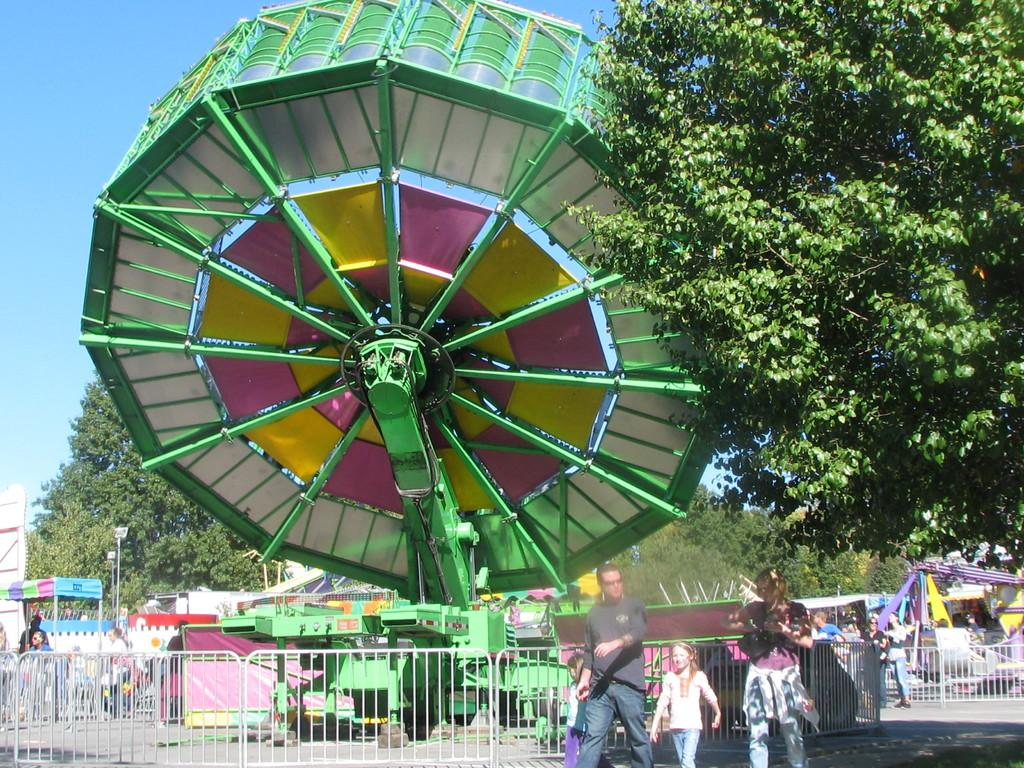What is happening in the image? There is an exhibition in the image. What can be seen surrounding the exhibition area? There is a fence and trees in the image. Are there any people present in the image? Yes, there are people in the image. What is on the ground in the image? There are objects on the ground in the image. What is visible in the background of the image? The sky is visible in the background of the image. What type of bead is being used to decorate the birthday cake in the image? There is no birthday cake or beads present in the image; it features an exhibition with a fence, trees, people, objects on the ground, and a visible sky. --- Facts: 1. There is a car in the image. 2. The car is red. 3. The car has four wheels. 4. There is a road in the image. 5. The road is paved. Absurd Topics: parrot, sand, mountain Conversation: What is the main subject of the image? The main subject of the image is a car. What color is the car? The car is red. How many wheels does the car have? The car has four wheels. What is the surface of the road in the image? The road is paved. Reasoning: Let's think step by step in order to produce the conversation. We start by identifying the main subject of the image, which is the car. Then, we describe specific features of the car, such as its color and the number of wheels. Next, we observe the road in the image and describe its surface. Each question is designed to elicit a specific detail about the image that is known from the provided facts. Absurd Question/Answer: Can you tell me how many parrots are sitting on the mountain in the image? There are no parrots or mountains present in the image; it features a red car with four wheels on a paved road. 